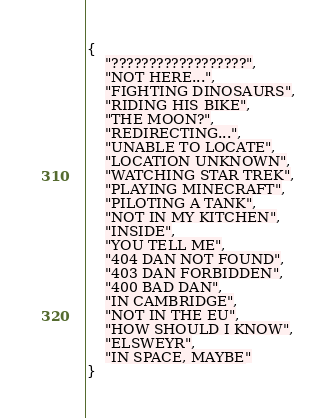Convert code to text. <code><loc_0><loc_0><loc_500><loc_500><_Lua_>{
	"??????????????????",
	"NOT HERE...",
	"FIGHTING DINOSAURS",
	"RIDING HIS BIKE",
	"THE MOON?",
	"REDIRECTING...",
	"UNABLE TO LOCATE",
	"LOCATION UNKNOWN",
	"WATCHING STAR TREK",
	"PLAYING MINECRAFT",
	"PILOTING A TANK",
	"NOT IN MY KITCHEN",
	"INSIDE",
	"YOU TELL ME",
	"404 DAN NOT FOUND",
	"403 DAN FORBIDDEN",
	"400 BAD DAN",
	"IN CAMBRIDGE",
	"NOT IN THE EU",
	"HOW SHOULD I KNOW",
	"ELSWEYR",
	"IN SPACE, MAYBE"
}
</code> 